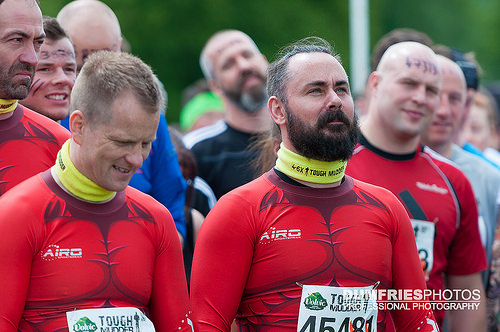<image>
Can you confirm if the human is on the other human? No. The human is not positioned on the other human. They may be near each other, but the human is not supported by or resting on top of the other human. 